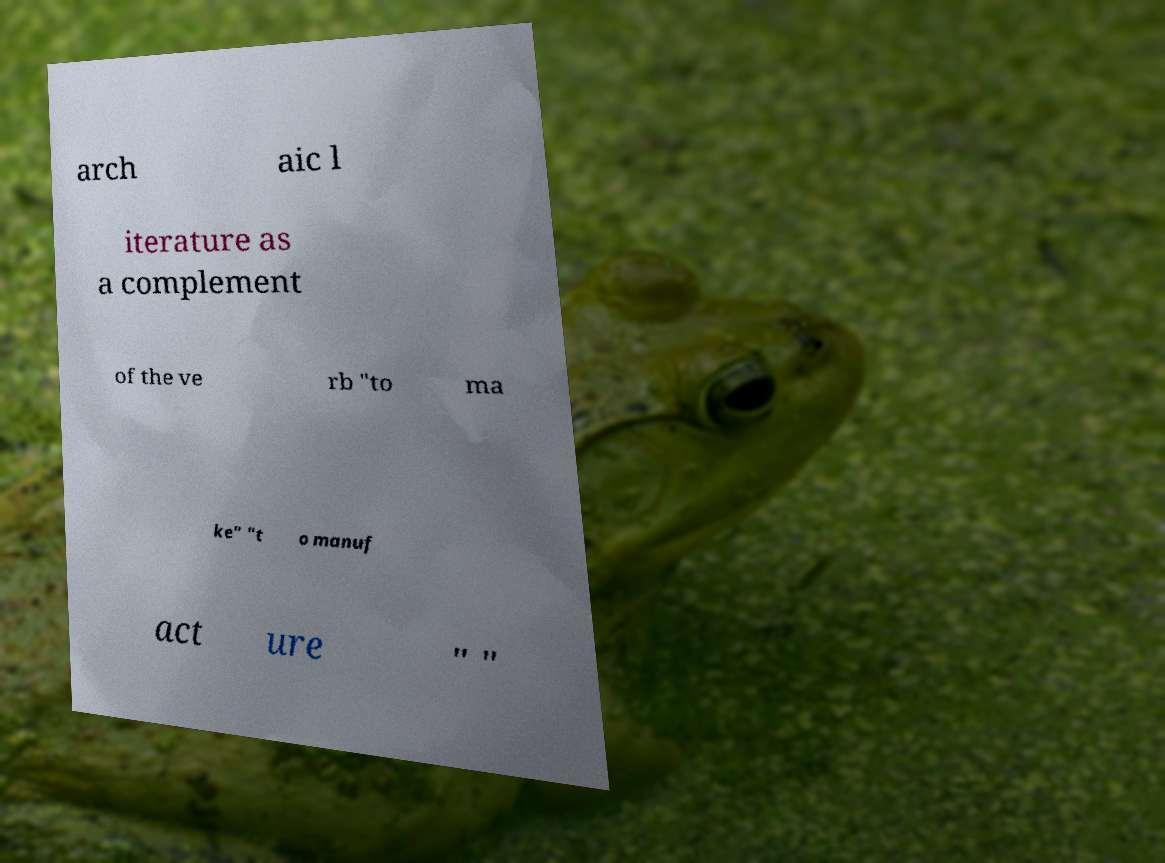I need the written content from this picture converted into text. Can you do that? arch aic l iterature as a complement of the ve rb "to ma ke" "t o manuf act ure " " 